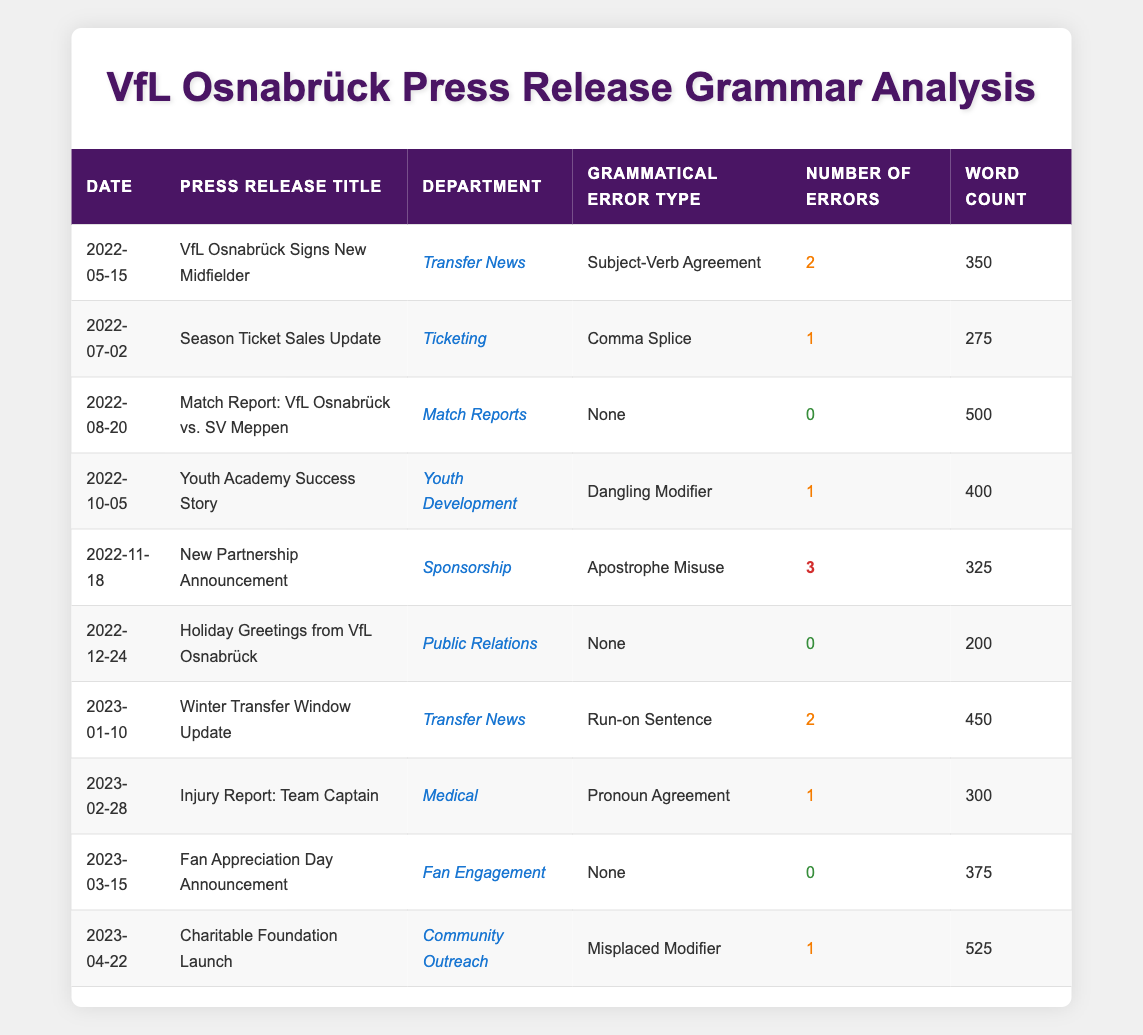What is the total number of grammatical errors in the press releases? To find the total number of grammatical errors, we sum the 'Number of Errors' from each press release. The specific counts are 2, 1, 0, 1, 3, 0, 2, 1, 0, and 1. Adding these gives us 2 + 1 + 0 + 1 + 3 + 0 + 2 + 1 + 0 + 1 = 11.
Answer: 11 Which press release had the highest number of grammatical errors? Looking at the 'Number of Errors' column, the press release titled "New Partnership Announcement" recorded the highest number at 3.
Answer: New Partnership Announcement How many press releases had no grammatical errors? We need to count how many 'Number of Errors' entries are 0. There are three press releases with 0 errors: "Match Report: VfL Osnabrück vs. SV Meppen", "Holiday Greetings from VfL Osnabrück", and "Fan Appreciation Day Announcement", making a total of 3.
Answer: 3 What is the average number of grammatical errors per press release? First, we sum the total number of errors, which is 11 (as calculated earlier). There are 10 press releases in total. To find the average, we divide the total errors by the number of press releases: 11 / 10 = 1.1.
Answer: 1.1 Is there any press release in the 'Transfer News' department that had more than 1 grammatical error? We review the 'Transfer News' entries, which are "VfL Osnabrück Signs New Midfielder" with 2 errors and "Winter Transfer Window Update" with 2 errors as well. Both had more than 1 grammatical error, so the answer is yes.
Answer: Yes How many different types of grammatical errors are mentioned in the table? By examining the 'Grammatical Error Type' column, we note the types listed: Subject-Verb Agreement, Comma Splice, Dangling Modifier, Apostrophe Misuse, Run-on Sentence, Pronoun Agreement, None, and Misplaced Modifier. That gives us a total of 7 different types, excluding the 'None' entries.
Answer: 7 Which department had the most press releases with grammatical errors? We analyze each department's entries and their corresponding errors. 'Transfer News' has 2 press releases with errors (2 and 2), 'Ticketing' has 1, 'Youth Development' has 1, 'Sponsorship' has 1, 'Medical' has 1, 'Community Outreach' has 1, while 'Match Reports' and 'Public Relations' had 0. Therefore, 'Transfer News' leads with 2.
Answer: Transfer News What was the total word count for the press releases that contained errors? We sum the 'Word Count' for press releases with errors: 350 (2 errors) + 275 (1 error) + 400 (1 error) + 325 (3 errors) + 450 (2 errors) + 300 (1 error) + 525 (1 error) = 2,125.
Answer: 2125 How many press releases were issued in 2023 compared to 2022? Reviewing the dates, there are 3 press releases in 2023: "Winter Transfer Window Update," "Injury Report: Team Captain," and "Charitable Foundation Launch." In contrast, there are 7 press releases in 2022. So, 2022 had more.
Answer: 2023: 3, 2022: 7 